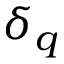<formula> <loc_0><loc_0><loc_500><loc_500>\delta _ { q }</formula> 